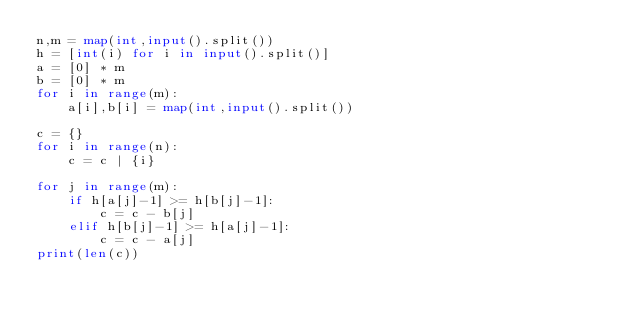Convert code to text. <code><loc_0><loc_0><loc_500><loc_500><_Python_>n,m = map(int,input().split())
h = [int(i) for i in input().split()]
a = [0] * m
b = [0] * m
for i in range(m):
    a[i],b[i] = map(int,input().split())

c = {}
for i in range(n):
    c = c | {i}

for j in range(m):
    if h[a[j]-1] >= h[b[j]-1]:
        c = c - b[j]
    elif h[b[j]-1] >= h[a[j]-1]:
        c = c - a[j]
print(len(c))
</code> 